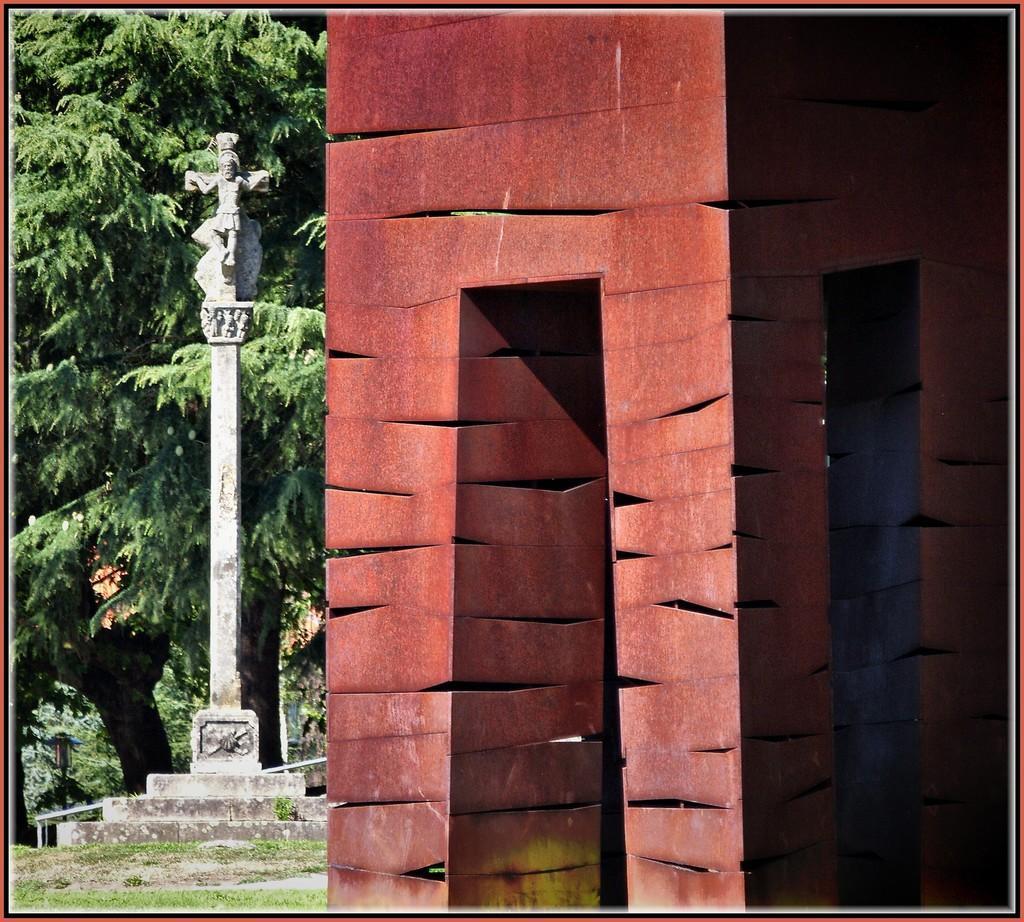Describe this image in one or two sentences. In this image in the right there is a building. In the left there is a monument. In the background there are trees. 